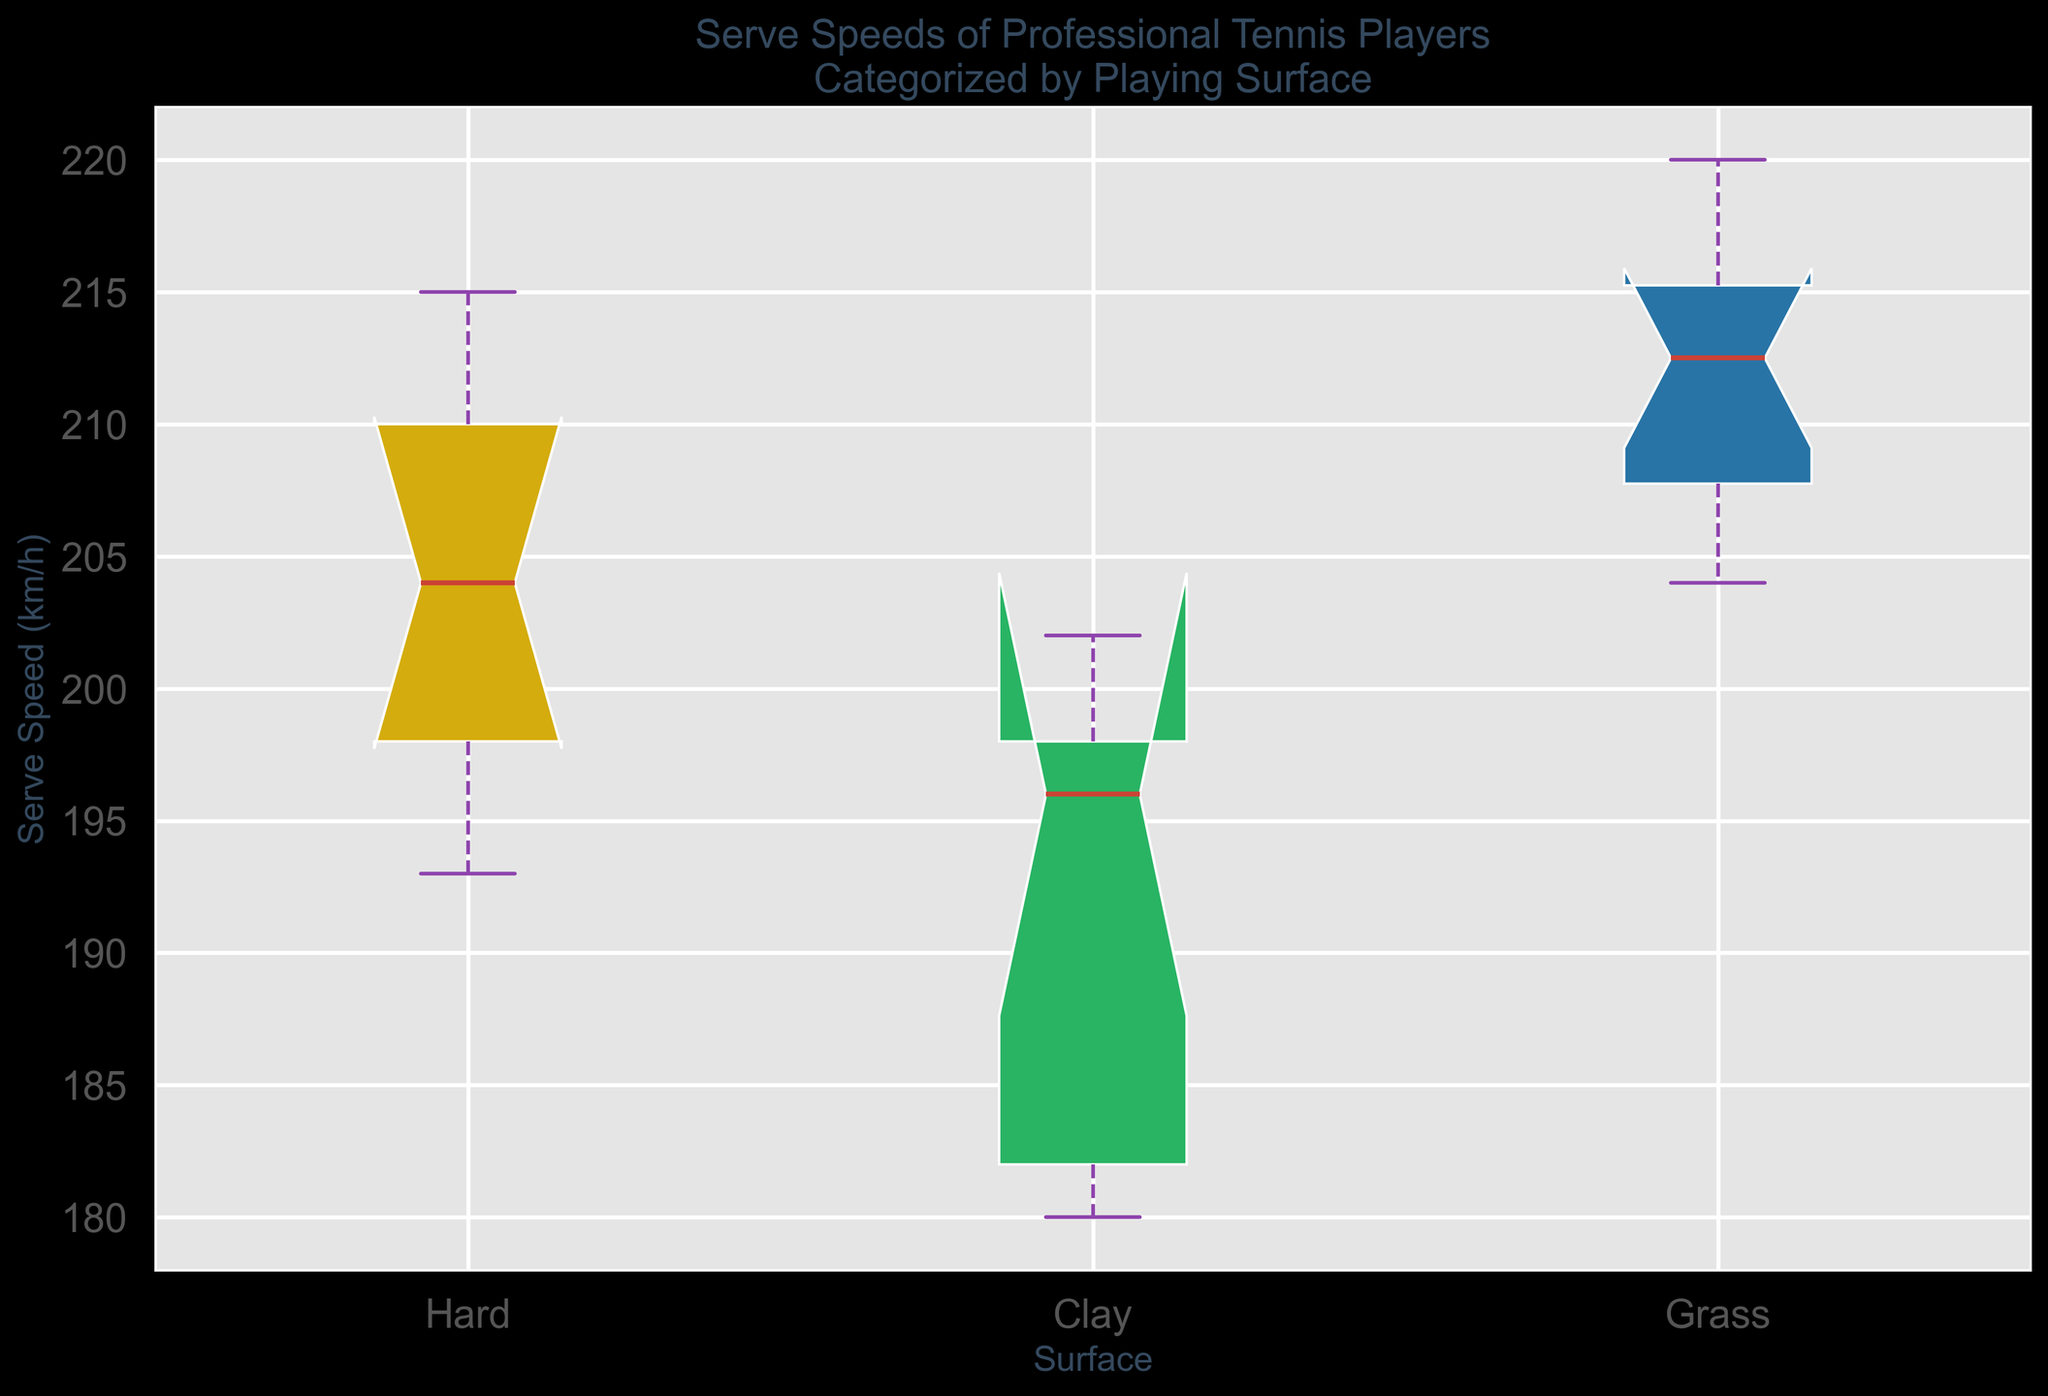What is the median serve speed on hard surfaces? The median is indicated by the red line in the box plot for hard surfaces.
Answer: 204 km/h Which surface shows the highest median serve speed? By comparing the red median lines across all box plots, the median on grass surfaces is the highest.
Answer: Grass What is the interquartile range (IQR) of serve speeds on clay surfaces? The IQR is the difference between the upper quartile (Q3) and the lower quartile (Q1), indicated by the edges of the box. Estimate these values on the clay box plot and calculate the difference.
Answer: 200 - 182 = 18 km/h How does the variability in serve speeds compare between grass and hard surfaces? The variability can be assessed by the range (distance between the whiskers) of each box plot. Grass has a wider range, indicating more variability.
Answer: Grass has higher variability Which surface has the widest range of serve speeds? The range is depicted by the distance between the top and bottom whiskers for each box plot. The grass surface has the widest range.
Answer: Grass Are there any potential outliers in serve speeds on any surface? Outliers are often indicated by points outside the whiskers in a box plot. The grass plot suggests potential outliers as seen by individual points.
Answer: Yes, on Grass What is the maximum serve speed recorded on grass surfaces? The maximum value is indicated by the top whisker or individual points above the whisker for the grass box plot.
Answer: 220 km/h Which surface sees the least variation in serve speeds? The surface with the smallest range (distance between the whiskers) shows the least variation. The clay surface shows the least variation.
Answer: Clay Compare the median serve speed of Rafael Nadal on hard and clay surfaces. By estimating the approximate median from the box plots of hard and clay surfaces where Rafael Nadal's serves are included, this can be compared.
Answer: 204 km/h on Hard, 196 km/h on Clay Is the first quartile of serve speeds on hard surfaces higher than the third quartile on clay surfaces? The first quartile (Q1) is the lower edge of the box, and the third quartile (Q3) is the upper edge. Compare Q1 from the hard surface box plot to Q3 from the clay surface box plot.
Answer: Yes 